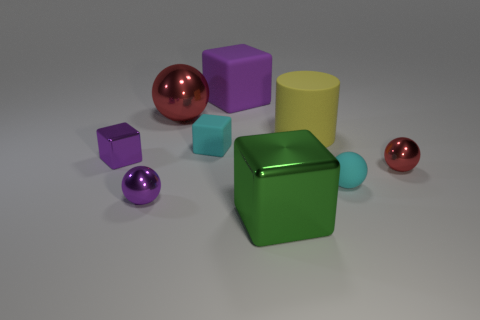The small metal object that is in front of the tiny red metal ball has what shape?
Offer a terse response. Sphere. What is the shape of the cyan object that is the same size as the cyan ball?
Ensure brevity in your answer.  Cube. Is there a tiny red object that has the same shape as the big yellow object?
Offer a terse response. No. Does the large matte thing behind the large matte cylinder have the same shape as the purple metal object that is in front of the small red shiny thing?
Offer a terse response. No. What material is the purple sphere that is the same size as the cyan ball?
Your answer should be very brief. Metal. What number of other things are there of the same material as the small purple sphere
Offer a terse response. 4. There is a big green object right of the metallic sphere in front of the small cyan rubber sphere; what is its shape?
Offer a terse response. Cube. How many objects are either cyan balls or large metallic objects that are right of the big sphere?
Your response must be concise. 2. How many other things are the same color as the tiny matte block?
Your answer should be compact. 1. How many purple things are either large matte objects or metallic blocks?
Provide a succinct answer. 2. 